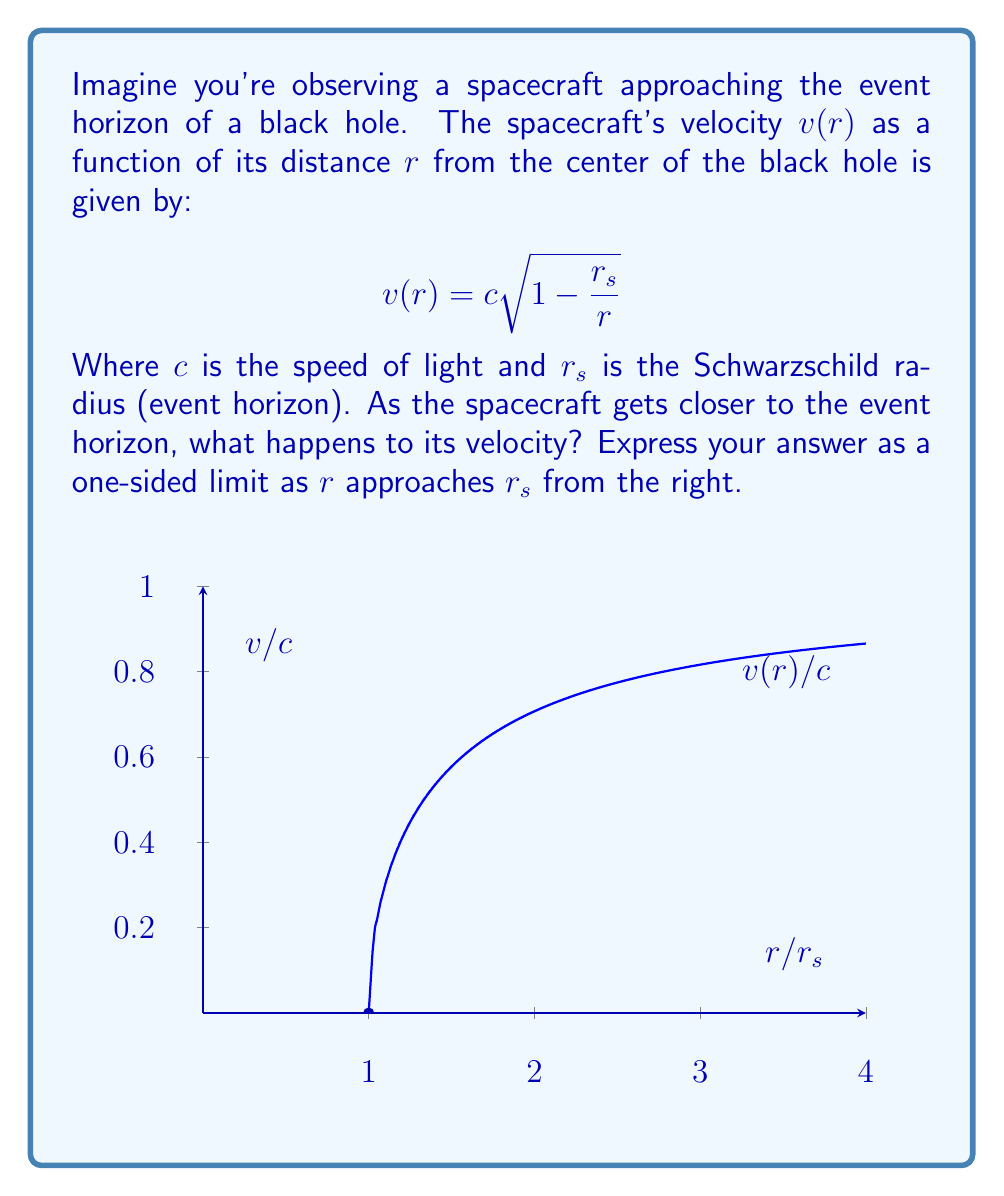Can you solve this math problem? Let's approach this step-by-step:

1) We're looking at the limit of $v(r)$ as $r$ approaches $r_s$ from the right. This can be expressed as:

   $$\lim_{r \to r_s^+} v(r) = \lim_{r \to r_s^+} c\sqrt{1 - \frac{r_s}{r}}$$

2) To evaluate this limit, let's consider what happens inside the square root as $r$ gets very close to $r_s$:

   $$\lim_{r \to r_s^+} \left(1 - \frac{r_s}{r}\right) = 1 - \lim_{r \to r_s^+} \frac{r_s}{r} = 1 - 1 = 0$$

3) So, our limit becomes:

   $$\lim_{r \to r_s^+} v(r) = c\sqrt{0} = 0$$

4) Physically, this means that as the spacecraft approaches the event horizon, its velocity as measured by an outside observer approaches the speed of light. However, at the event horizon itself, the velocity becomes zero.

5) This apparent paradox is due to the extreme time dilation near the event horizon. From the spacecraft's perspective, it's still moving, but from an outside observer's view, it appears to slow down and stop at the horizon.
Answer: $\lim_{r \to r_s^+} v(r) = c$ 